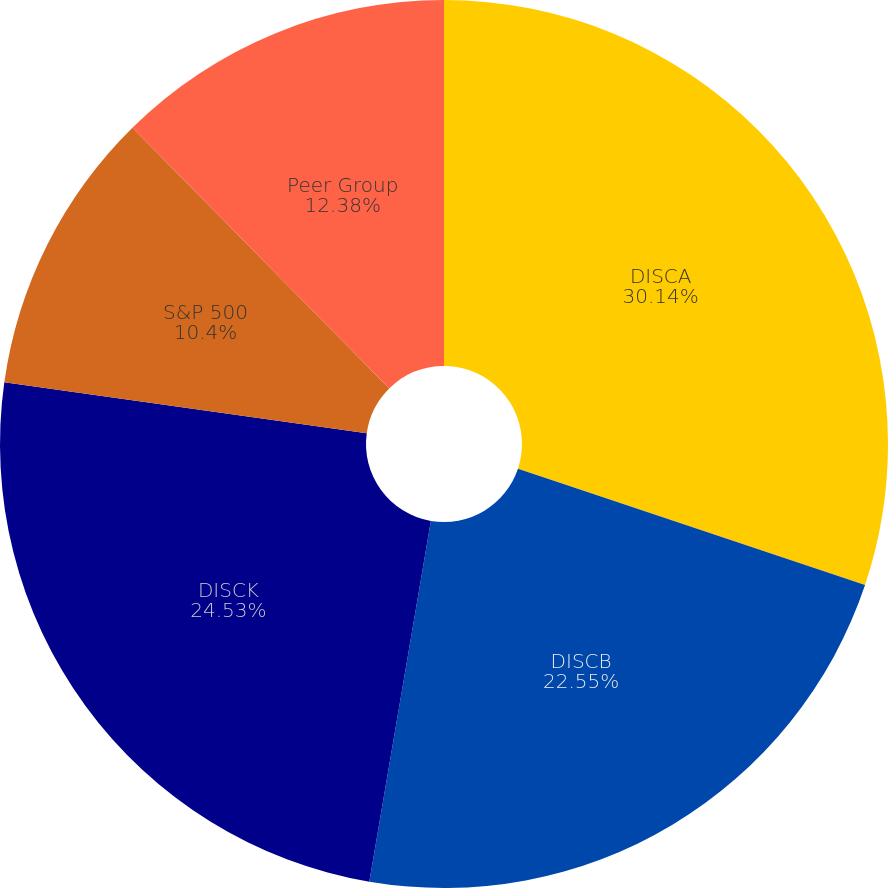<chart> <loc_0><loc_0><loc_500><loc_500><pie_chart><fcel>DISCA<fcel>DISCB<fcel>DISCK<fcel>S&P 500<fcel>Peer Group<nl><fcel>30.14%<fcel>22.55%<fcel>24.53%<fcel>10.4%<fcel>12.38%<nl></chart> 